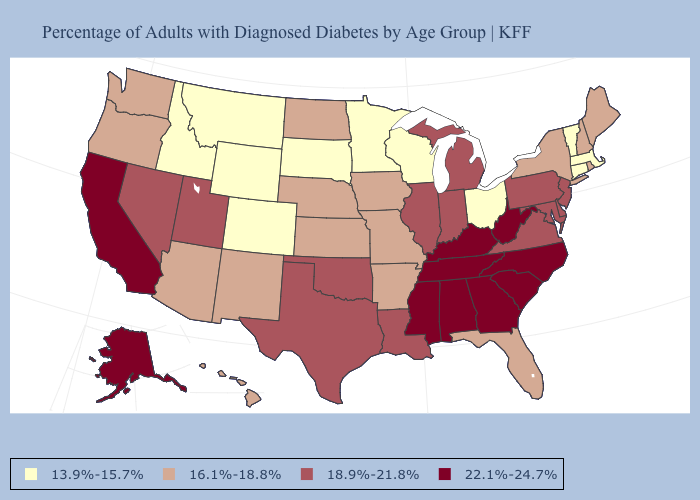What is the lowest value in the USA?
Quick response, please. 13.9%-15.7%. What is the value of Kentucky?
Keep it brief. 22.1%-24.7%. Name the states that have a value in the range 18.9%-21.8%?
Keep it brief. Delaware, Illinois, Indiana, Louisiana, Maryland, Michigan, Nevada, New Jersey, Oklahoma, Pennsylvania, Texas, Utah, Virginia. What is the value of Kansas?
Concise answer only. 16.1%-18.8%. Name the states that have a value in the range 16.1%-18.8%?
Give a very brief answer. Arizona, Arkansas, Florida, Hawaii, Iowa, Kansas, Maine, Missouri, Nebraska, New Hampshire, New Mexico, New York, North Dakota, Oregon, Rhode Island, Washington. What is the highest value in the West ?
Give a very brief answer. 22.1%-24.7%. What is the value of West Virginia?
Be succinct. 22.1%-24.7%. What is the value of Delaware?
Keep it brief. 18.9%-21.8%. What is the value of Mississippi?
Give a very brief answer. 22.1%-24.7%. Among the states that border Maryland , does Pennsylvania have the lowest value?
Write a very short answer. Yes. Name the states that have a value in the range 18.9%-21.8%?
Short answer required. Delaware, Illinois, Indiana, Louisiana, Maryland, Michigan, Nevada, New Jersey, Oklahoma, Pennsylvania, Texas, Utah, Virginia. What is the lowest value in the MidWest?
Answer briefly. 13.9%-15.7%. What is the highest value in states that border South Dakota?
Short answer required. 16.1%-18.8%. 